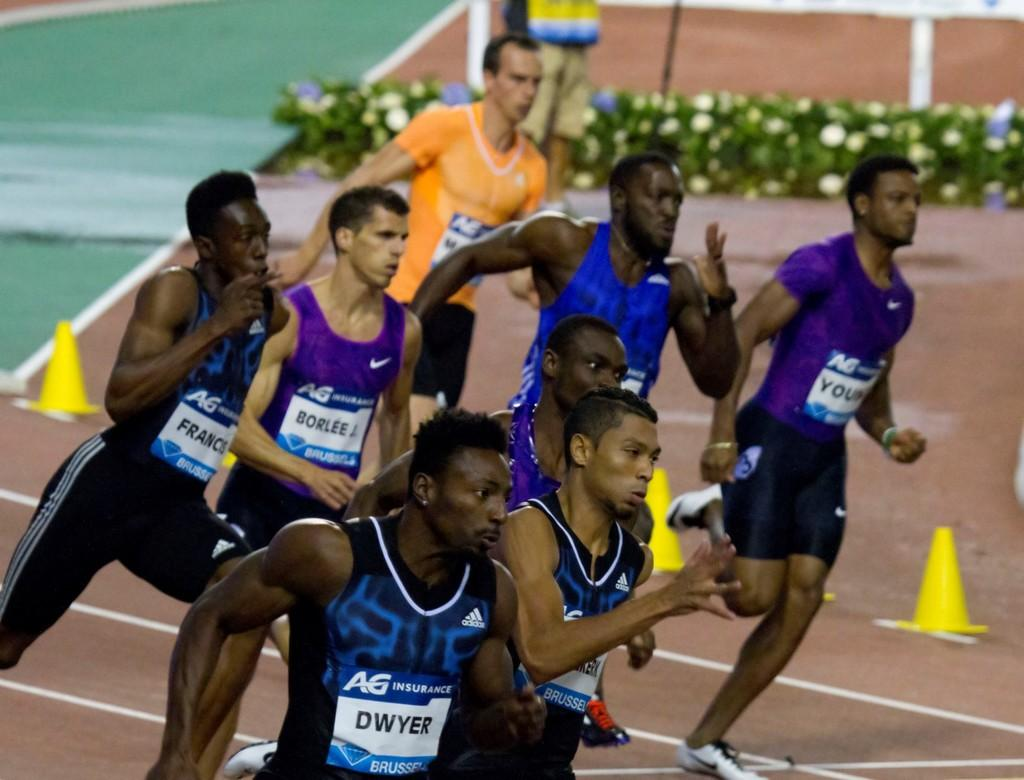What are the people in the image doing? The people in the image are running. What objects can be seen in the image besides the people? There are cones in the image. What can be seen in the background of the image? There are flower plants in the background of the image. What type of lunch is being served in the image? There is no lunch present in the image; it features people running and cones. Can you tell me who the guide is in the image? There is no guide present in the image; it only shows people running and cones. 